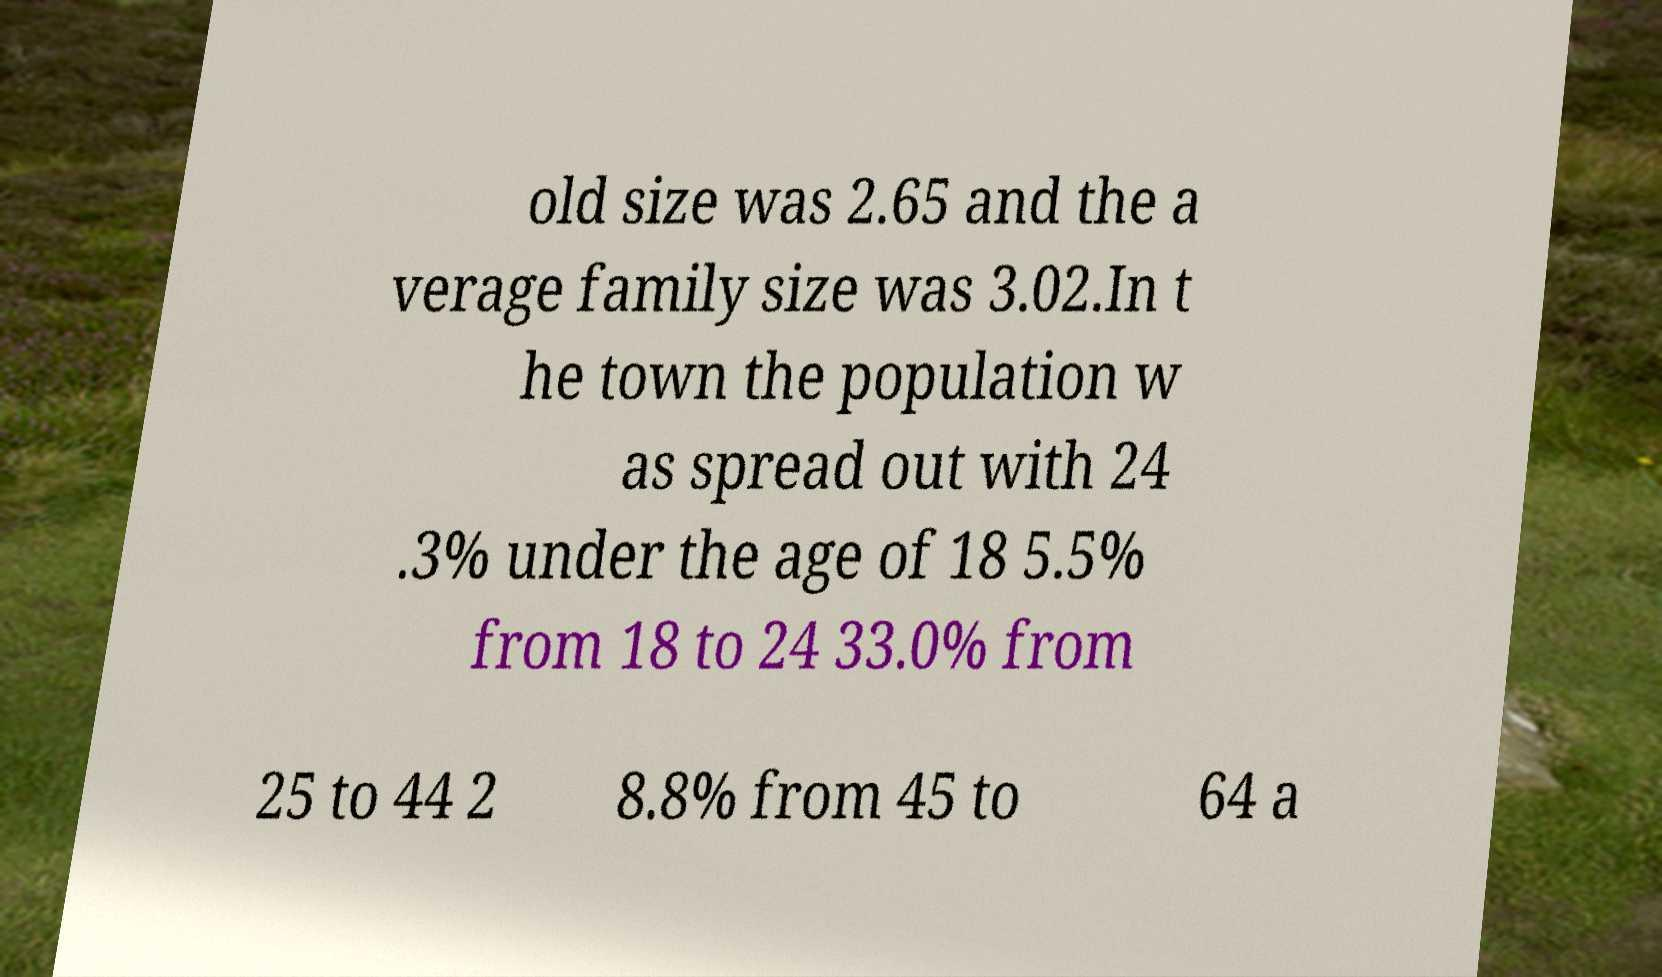Please read and relay the text visible in this image. What does it say? old size was 2.65 and the a verage family size was 3.02.In t he town the population w as spread out with 24 .3% under the age of 18 5.5% from 18 to 24 33.0% from 25 to 44 2 8.8% from 45 to 64 a 